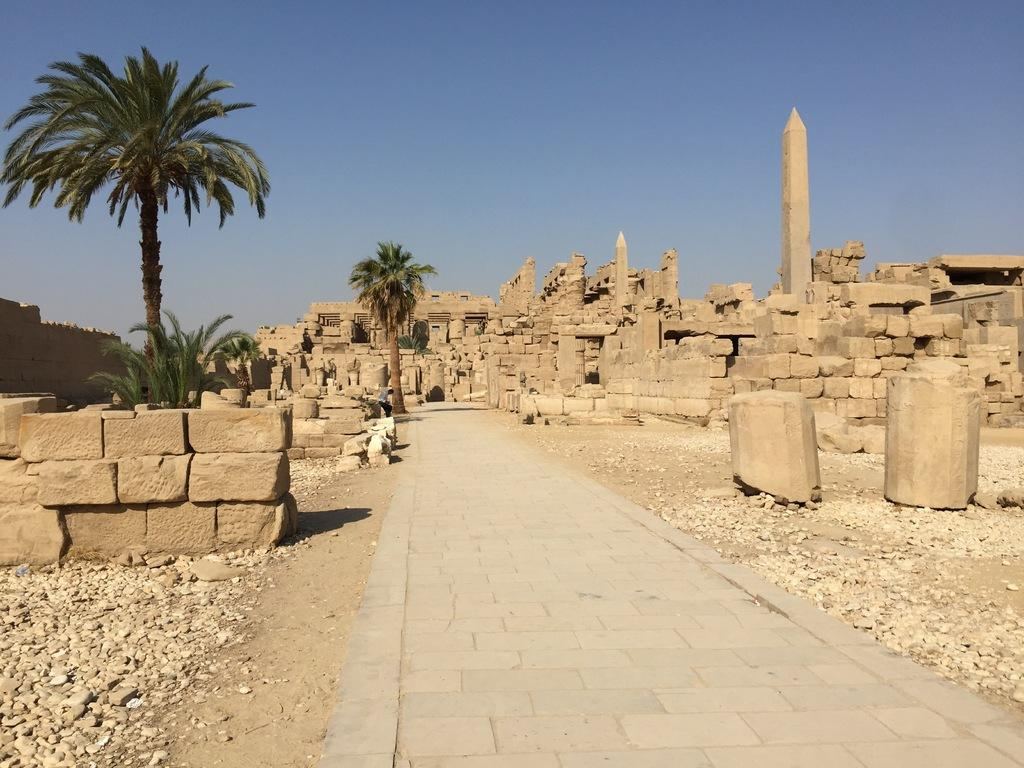What type of structures can be seen in the image? There are forts in the image. What natural elements are present in the image? There are rocks, stones, trees, and the sky visible in the image. Can you describe the person in the image? There is a person in the image, but no specific details about their appearance or actions are provided. What type of line can be seen connecting the forts in the image? There is no line connecting the forts in the image; the forts are separate structures. Can you describe the bird perched on the tree in the image? There is no bird present in the image; only forts, rocks, stones, trees, and a person are mentioned. 